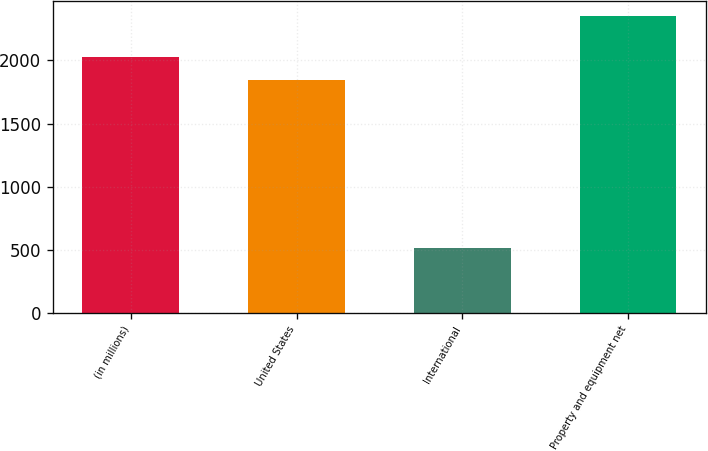Convert chart. <chart><loc_0><loc_0><loc_500><loc_500><bar_chart><fcel>(in millions)<fcel>United States<fcel>International<fcel>Property and equipment net<nl><fcel>2030.6<fcel>1846<fcel>510<fcel>2356<nl></chart> 